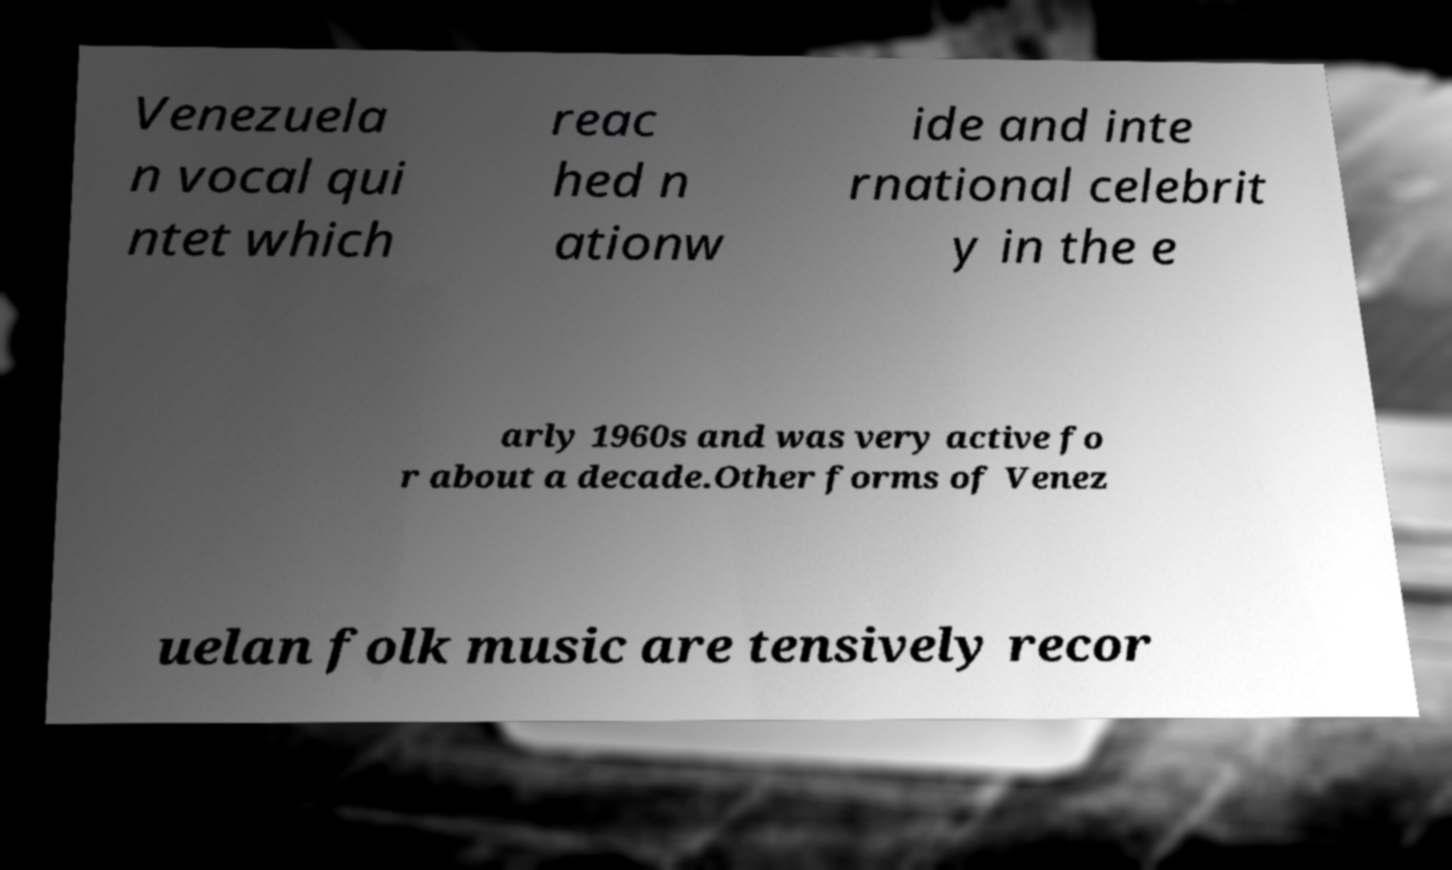I need the written content from this picture converted into text. Can you do that? Venezuela n vocal qui ntet which reac hed n ationw ide and inte rnational celebrit y in the e arly 1960s and was very active fo r about a decade.Other forms of Venez uelan folk music are tensively recor 